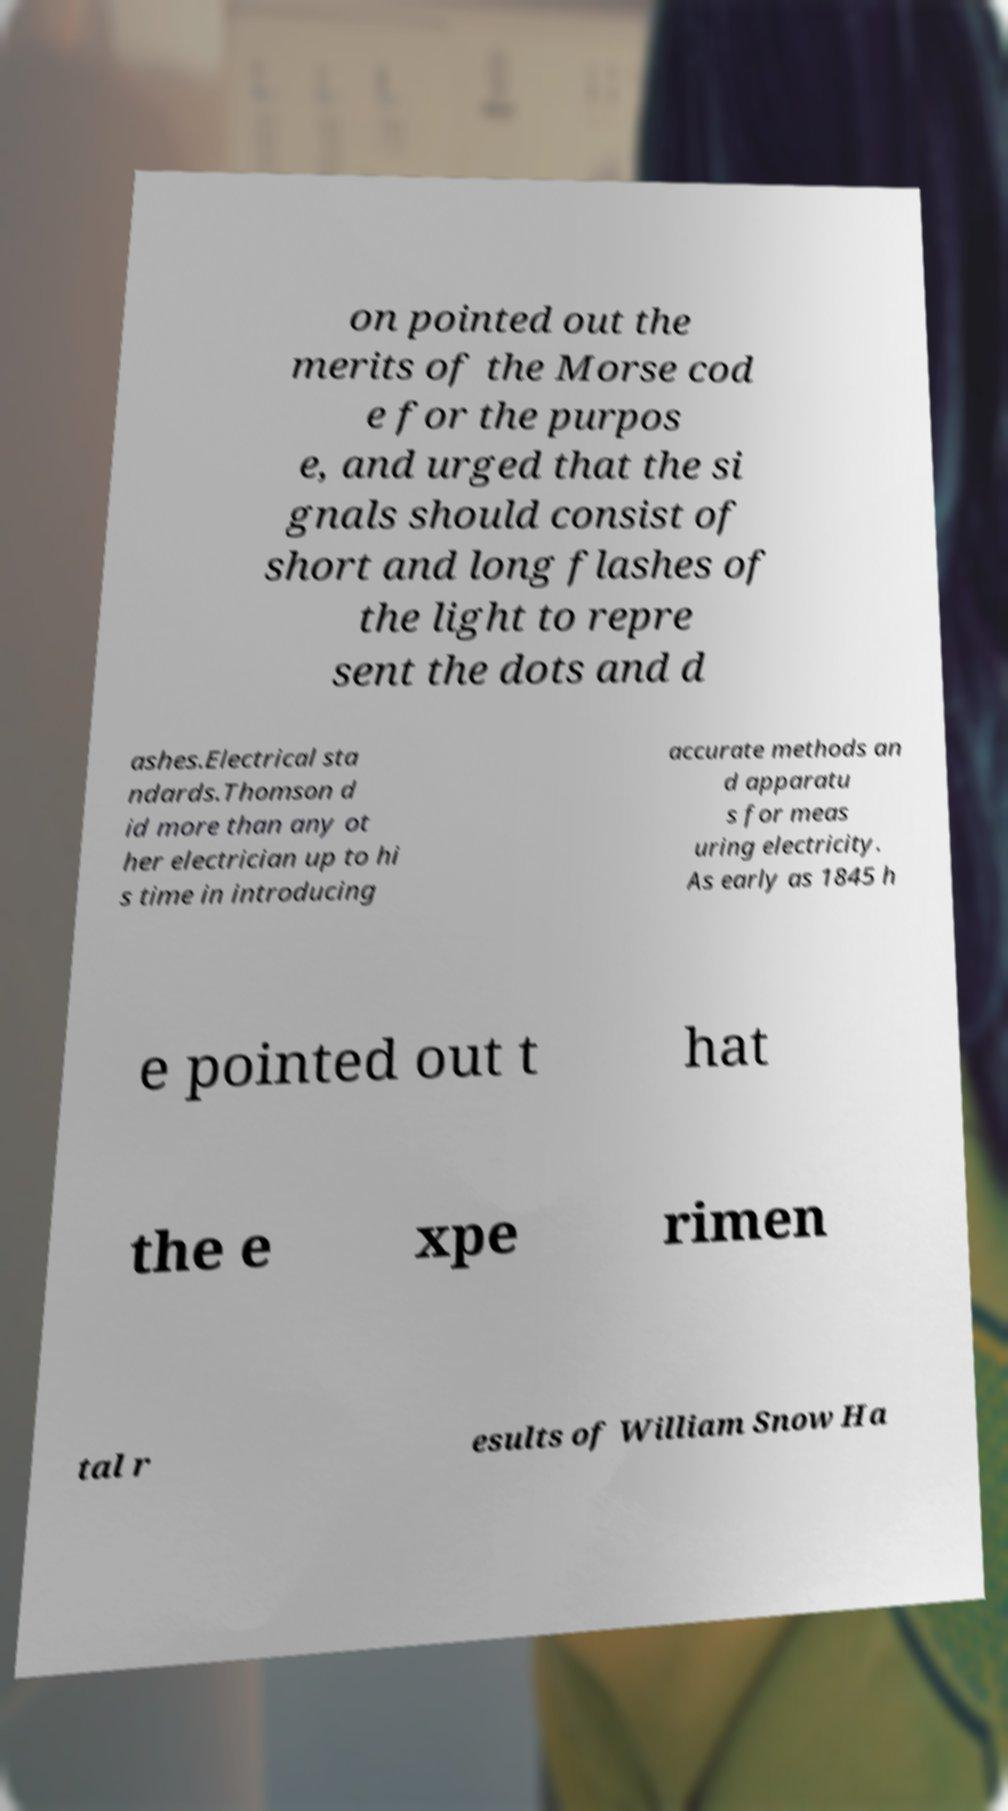What messages or text are displayed in this image? I need them in a readable, typed format. on pointed out the merits of the Morse cod e for the purpos e, and urged that the si gnals should consist of short and long flashes of the light to repre sent the dots and d ashes.Electrical sta ndards.Thomson d id more than any ot her electrician up to hi s time in introducing accurate methods an d apparatu s for meas uring electricity. As early as 1845 h e pointed out t hat the e xpe rimen tal r esults of William Snow Ha 